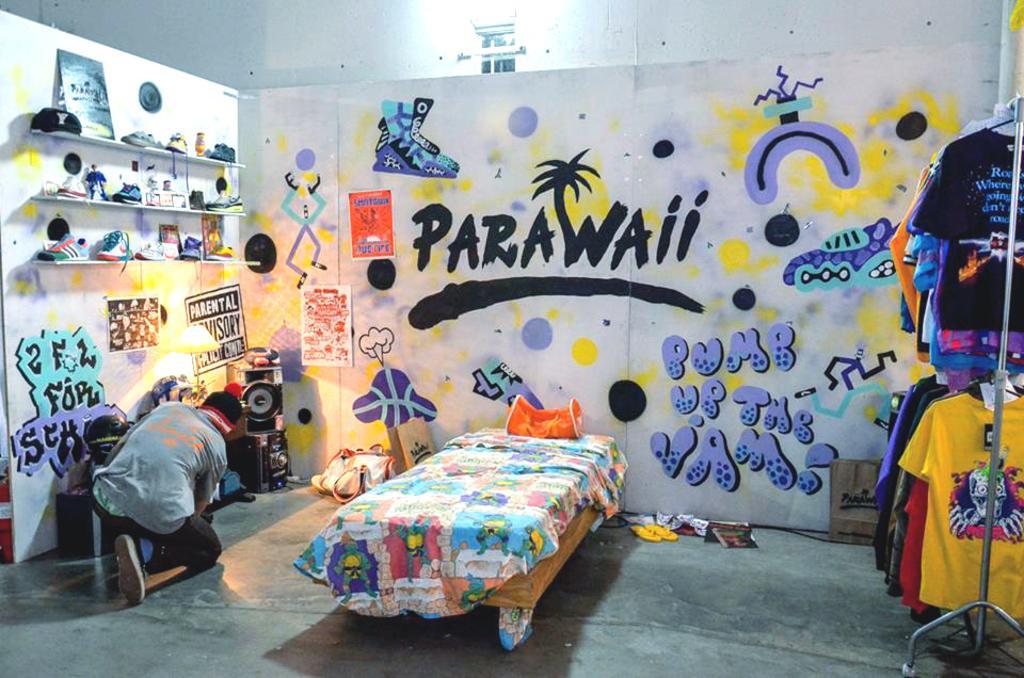Can you describe this image briefly? In this image I can see the floor, few clothes hanged to the metal rods, a person, few racks with few shoes and few objects in them. I can see the wall with few poster attached to it and few paintings on it. In the background I can see the white colored wall and a light. 